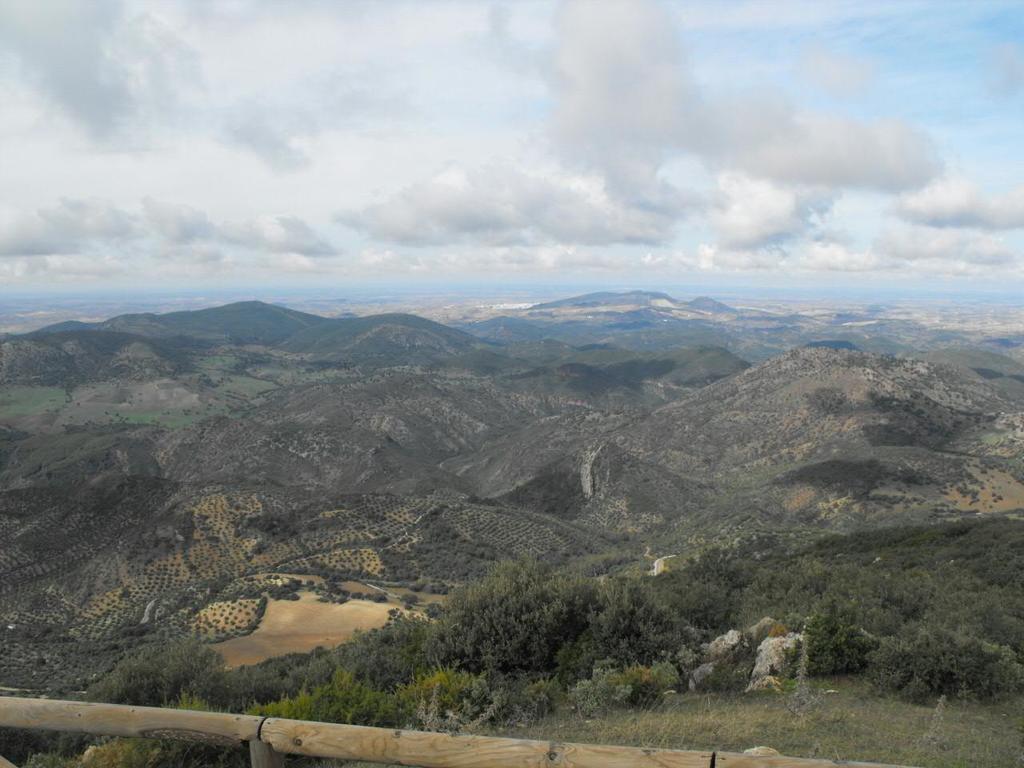Please provide a concise description of this image. In this picture we can see some greenery and a few mountains are visible in the background. Sky is cloudy. 